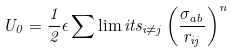Convert formula to latex. <formula><loc_0><loc_0><loc_500><loc_500>U _ { 0 } = \frac { 1 } { 2 } \epsilon \sum \lim i t s _ { i \ne j } \left ( \frac { \sigma _ { a b } } { r _ { i j } } \right ) ^ { n }</formula> 